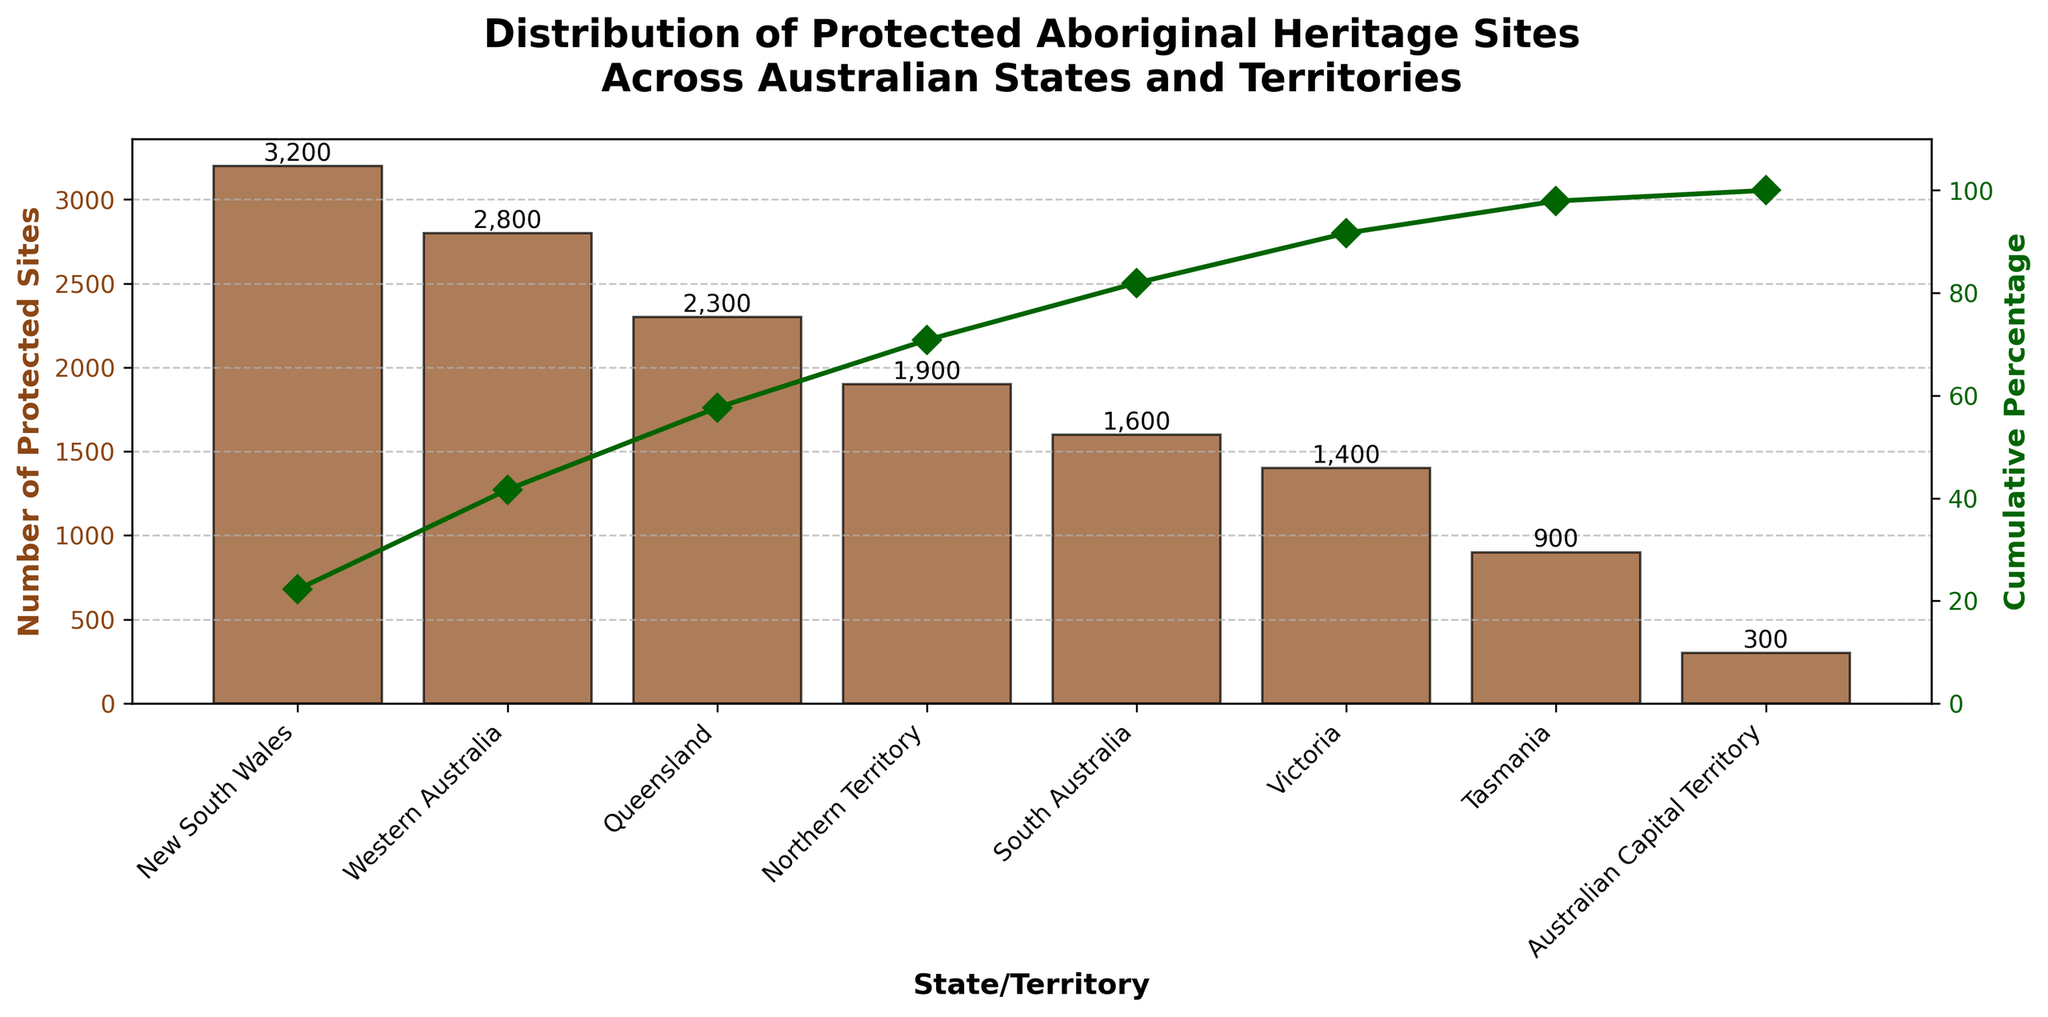What is the state or territory with the highest number of protected Aboriginal heritage sites? The title specifies that the figure displays the distribution of protected Aboriginal heritage sites across Australian states and territories. By examining the highest bar in the chart, we see that New South Wales has the highest number of protected sites.
Answer: New South Wales What is the total number of protected Aboriginal heritage sites across all states and territories? To find the total number, we need to add up the values of protected sites for all states and territories: 3200 (NSW) + 2800 (WA) + 2300 (QLD) + 1900 (NT) + 1600 (SA) + 1400 (VIC) + 900 (TAS) + 300 (ACT) = 14400.
Answer: 14400 Looking at the cumulative percentage, at which state or territory does the cumulative percentage surpass 50% for the first time? By examining the cumulative percentage plot, we observe the rising values. The cumulative percentage surpasses 50% right after New South Wales and Western Australia are considered, indicating that it happens by the time we reach Queensland.
Answer: Queensland How many more protected Aboriginal heritage sites does Western Australia have compared to Tasmania? Western Australia has 2800 and Tasmania has 900. The difference between them is 2800 - 900, which equals 1900.
Answer: 1900 Which state or territory has the lowest number of protected Aboriginal heritage sites? By identifying the shortest bar in the chart, we find that the Australian Capital Territory has the lowest number of protected sites.
Answer: Australian Capital Territory What is the cumulative percentage after considering the heritage sites in Victoria? By examining the cumulative percentage plot, we observe that after considering Victoria, the cumulative percentage reaches a specific value on the y-axis of the right-hand side. It is around 89% (approximated from the plot).
Answer: 89% What is the ratio of protected Aboriginal heritage sites in South Australia compared to the total number? South Australia has 1600 sites. The total number of sites is 14400. The ratio is 1600 / 14400, which simplifies to approximately 0.111.
Answer: 0.111 What is the cumulative percentage up to New South Wales? From the cumulative percentage line, we can see that by the time we finish counting New South Wales, the cumulative percentage is 22% (approximated from the plot).
Answer: 22% Which two states or territories combined contribute to roughly 42% of the total protected Aboriginal heritage sites? We can examine the cumulative percentage and look for the states whose cumulative percentage sums to around 42%. New South Wales (22%) and Western Australia (41.4%) combined approximate this value.
Answer: New South Wales and Western Australia How does the number of protected Aboriginal heritage sites in Queensland compare to New South Wales and Victoria combined? Queensland has 2300 sites. New South Wales has 3200, and Victoria has 1400. The sum of NSW and VIC is 3200 + 1400 = 4600, which is greater than 2300.
Answer: NSW and Victoria combined have more sites than Queensland 